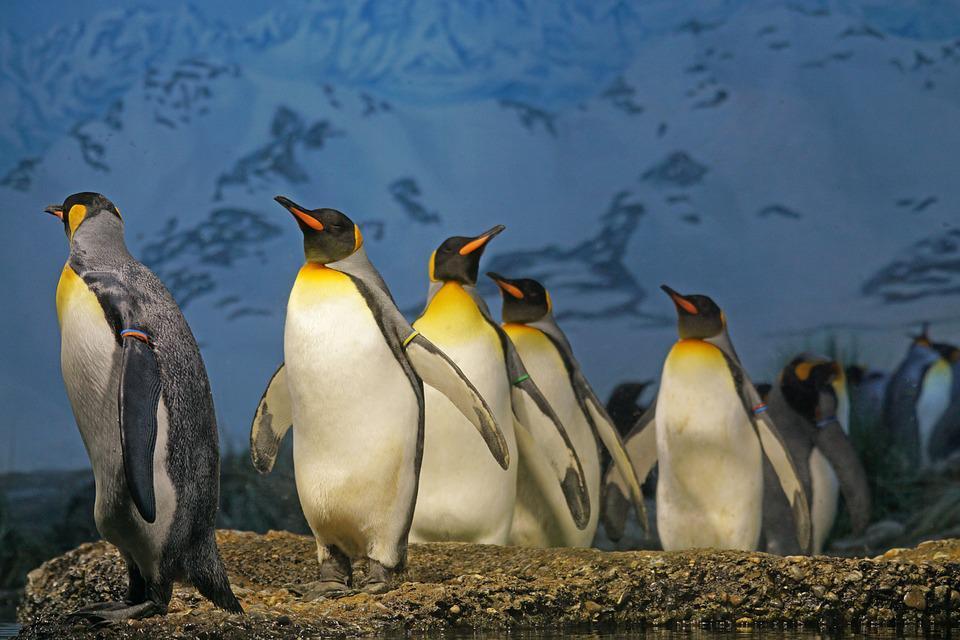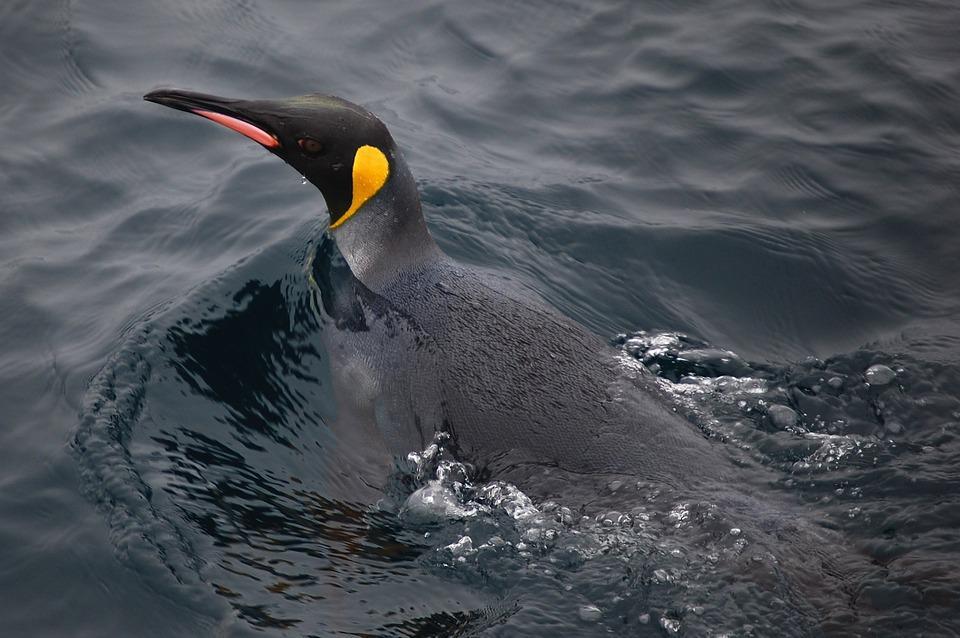The first image is the image on the left, the second image is the image on the right. Evaluate the accuracy of this statement regarding the images: "Each image contains a single penguin, and the penguins share similar body poses.". Is it true? Answer yes or no. No. The first image is the image on the left, the second image is the image on the right. For the images displayed, is the sentence "There are two penguins in the image pair." factually correct? Answer yes or no. No. 